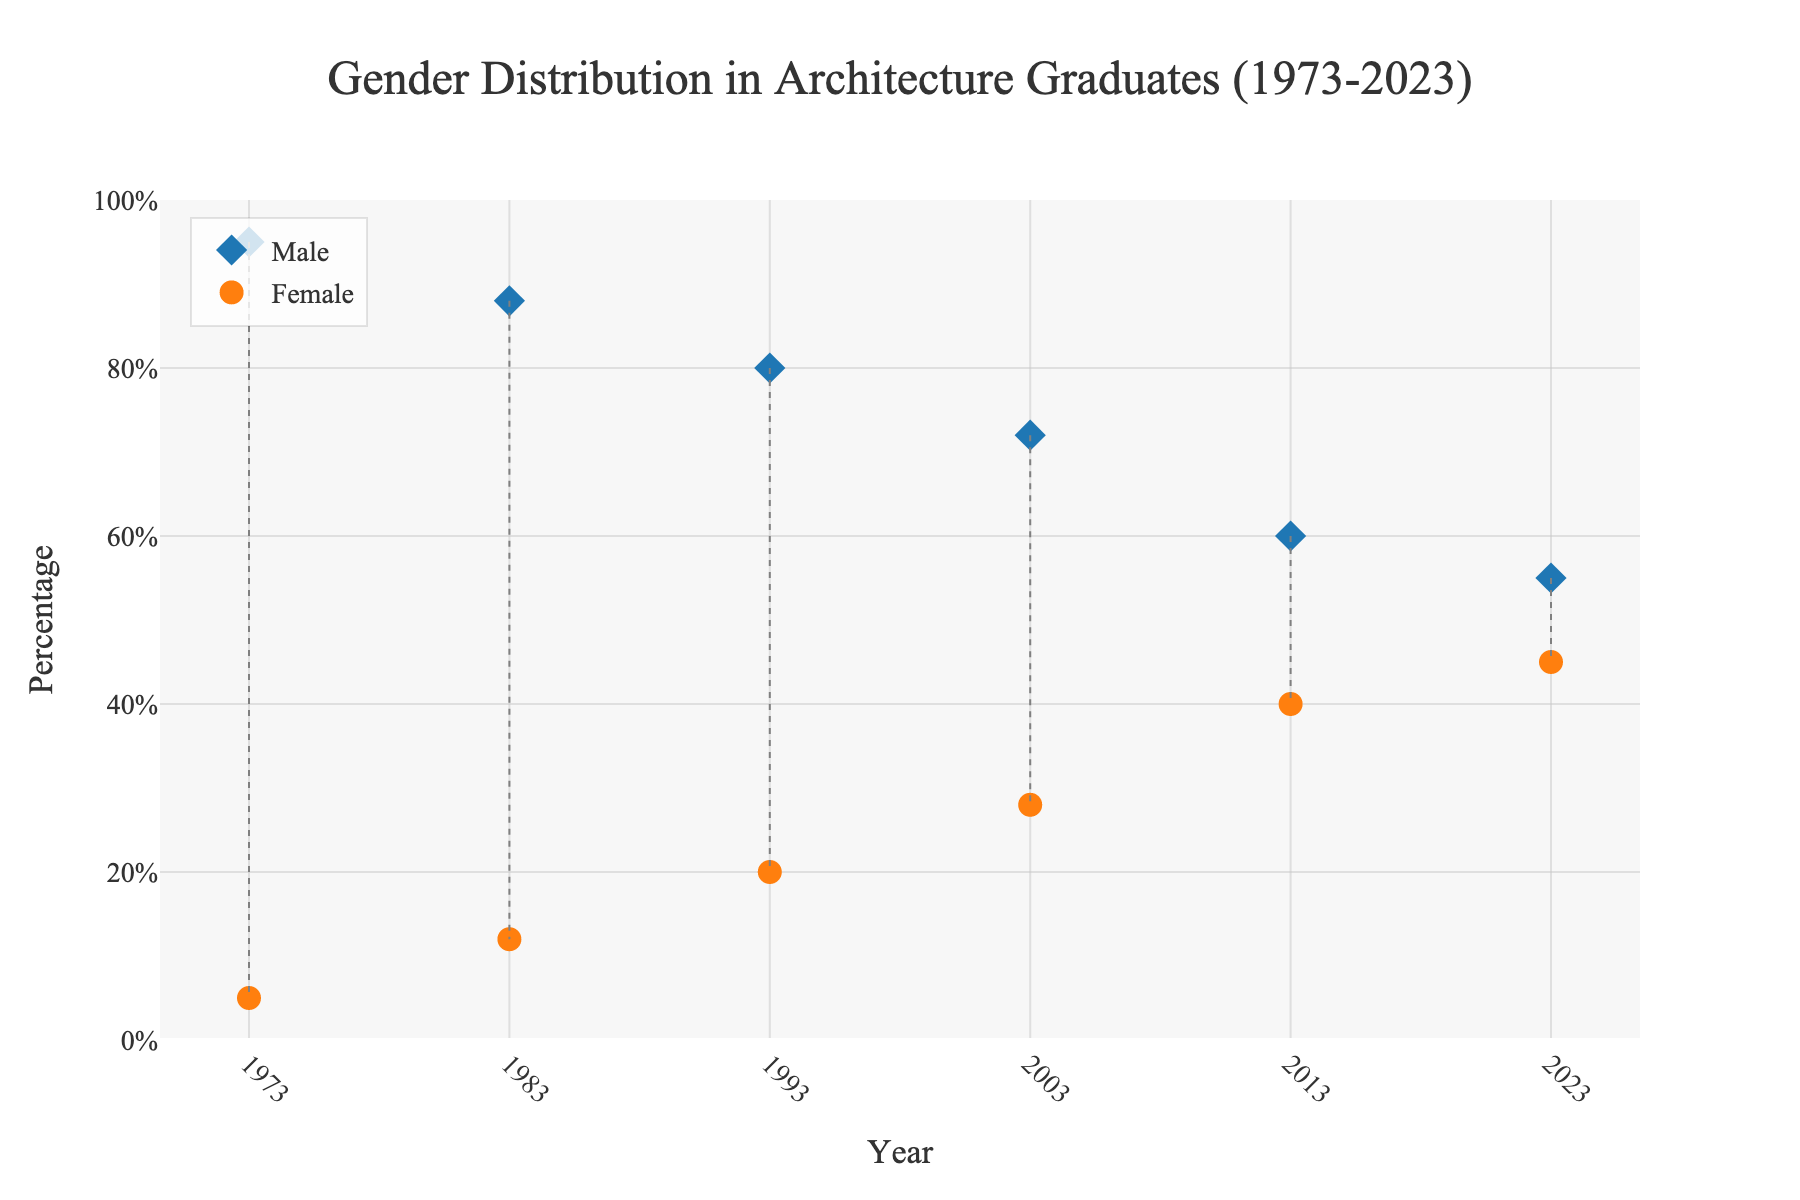what is the title of the plot? The title is located at the top of the plot in larger font size. It reads "Gender Distribution in Architecture Graduates (1973-2023)".
Answer: Gender Distribution in Architecture Graduates (1973-2023) how many data points are there for each gender? We have data points for six different years: 1973, 1983, 1993, 2003, 2013, and 2023. Each year has a data point for both male and female percentages. This gives 6 data points per gender.
Answer: 6 how does the percentage of female graduates change from 1973 to 2023? The percentage of female graduates in 1973 is 5% and increases to 45% in 2023. The change can be calculated as 45% - 5% = 40%.
Answer: 40% what is the trend in the percentage of male graduates over the years? Observing the data points for males: 95% in 1973, 88% in 1983, 80% in 1993, 72% in 2003, 60% in 2013, and 55% in 2023, we see a downward trend in the percentage of male graduates over the years.
Answer: Decreasing trend in which year is the difference between male and female graduates' percentages the smallest? The smallest difference is where the gap between male and female percentages is the closest. By calculating the differences for each year: 1973 (90), 1983 (76), 1993 (60), 2003 (44), 2013 (20), and 2023 (10), we find the smallest difference in 2023.
Answer: 2023 what is the average percentage of female graduates in the 1990s? The 1990s data point is 1993, where the percentage of female graduates is 20%. Since there's only one point in that decade, the average is 20%.
Answer: 20% how are the male and female percentages represented differently on the plot? The plot uses different marker shapes and colors for male and female percentages. Male percentages are represented with blue diamond markers, while female percentages are shown with orange circle markers. Individual years are connected by dashed gray lines.
Answer: Different marker shapes and colors what can you infer about the gender distribution trend in architecture graduates from 1973 to 2023? Over the years, the percentage of female graduates has steadily increased, while the percentage of male graduates has steadily decreased. This reflects a trend towards more balanced gender distribution in architecture graduates.
Answer: More balanced gender distribution which year shows the most balanced gender distribution in architecture graduates? By comparing the percentages of male and female graduates across all years, we find that the year 2023, with 55% male and 45% female graduates, is the most balanced.
Answer: 2023 